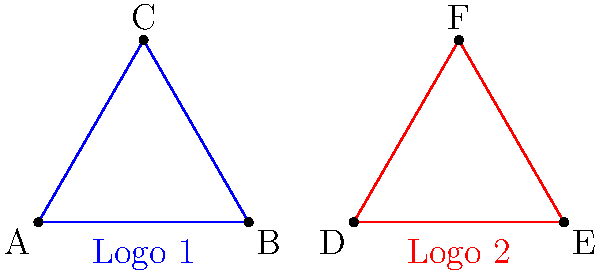Two rival record labels have similar triangular logos. Logo 1 (blue) has side lengths of 2, 2, and 2 units. Logo 2 (red) has side lengths of 2.5, 2.5, and 2.5 units. Are these logos congruent? If not, what transformation would make them congruent? To determine if the logos are congruent and identify any necessary transformations, let's follow these steps:

1. Definition of congruence: Two shapes are congruent if they have the same shape and size, meaning all corresponding angles are equal and all corresponding sides are proportional.

2. Compare side lengths:
   Logo 1: All sides are 2 units
   Logo 2: All sides are 2.5 units

3. Observe that the side lengths are not equal, but they are proportional:
   $\frac{2.5}{2} = 1.25$ for all sides

4. Compare angles:
   Both logos appear to be equilateral triangles, meaning all angles are 60°.

5. Conclusion on congruence:
   The logos are not congruent because they have different sizes, even though they have the same shape.

6. Transformation for congruence:
   To make Logo 1 congruent to Logo 2, we need to apply a dilation (scaling) with a scale factor of 1.25.

7. Mathematically, this transformation can be expressed as:
   $$(x', y') = 1.25(x, y)$$
   where $(x, y)$ are coordinates of points in Logo 1, and $(x', y')$ are the corresponding points in the transformed logo.
Answer: Not congruent; dilation with scale factor 1.25 